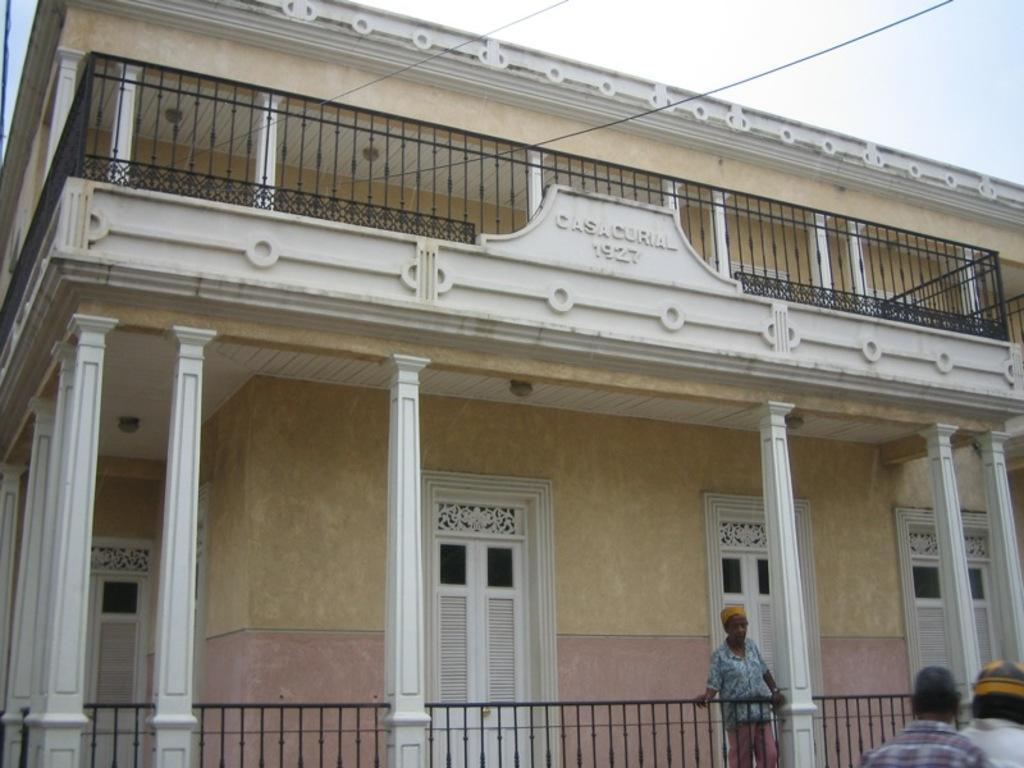Could you give a brief overview of what you see in this image? In this picture I can see a building, person standing in front of the grilles, side I can see few people at right side of the image. 